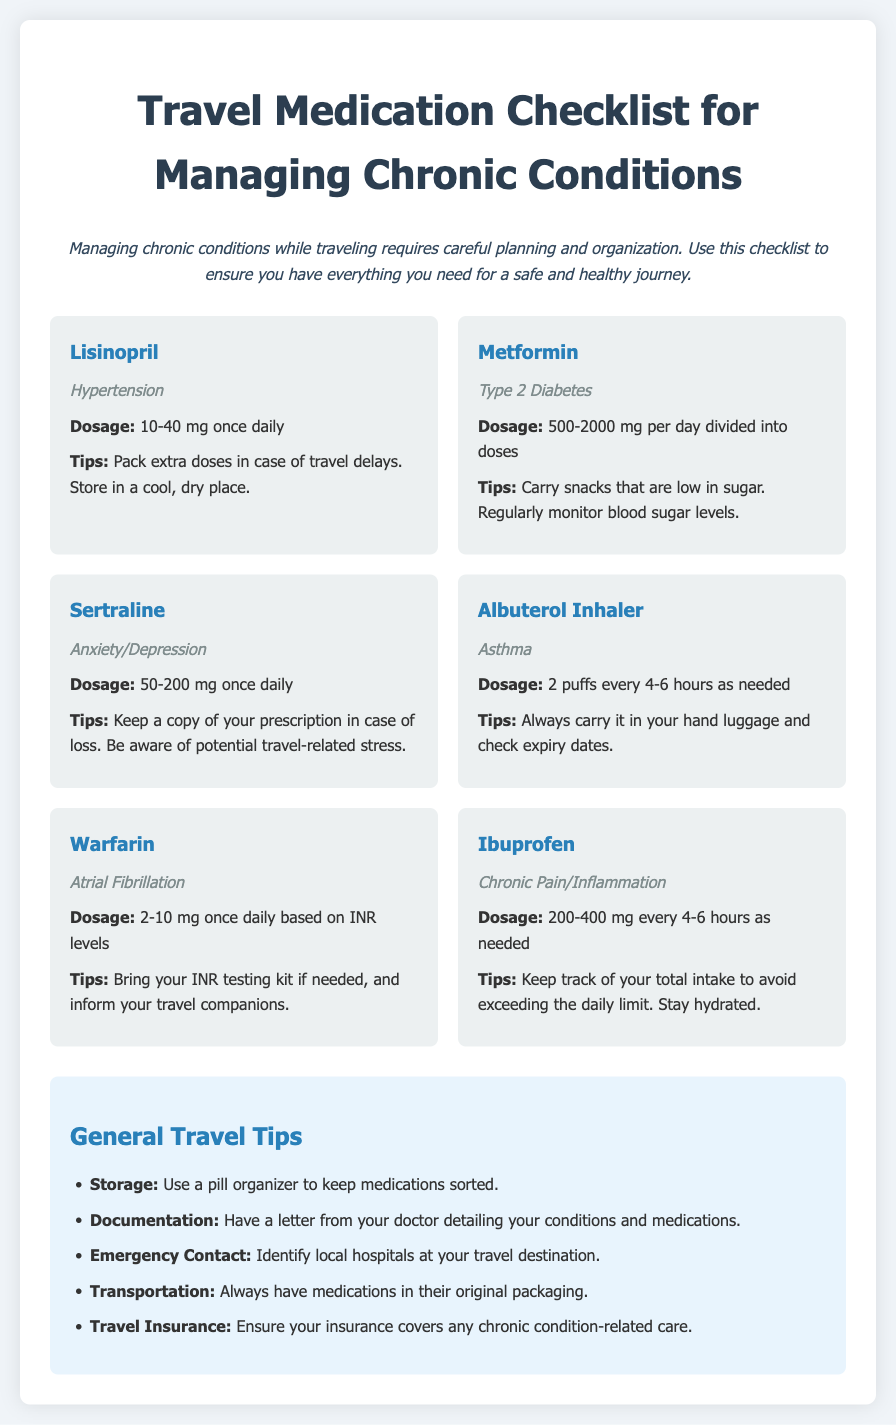What is the dosage for Lisinopril? The dosage for Lisinopril is specified as 10-40 mg once daily in the document.
Answer: 10-40 mg once daily How should Metformin be taken? The document states that Metformin should be taken as 500-2000 mg per day divided into doses.
Answer: 500-2000 mg per day divided into doses What condition is Sertraline prescribed for? The document indicates that Sertraline is prescribed for Anxiety/Depression.
Answer: Anxiety/Depression How many puffs of Albuterol Inhaler can be taken as needed? The document specifies that the dosage for Albuterol Inhaler is 2 puffs every 4-6 hours as needed.
Answer: 2 puffs every 4-6 hours What is a general travel tip regarding medication storage? The document suggests using a pill organizer to keep medications sorted.
Answer: Use a pill organizer What should you carry with you for emergency situations? According to the document, you should identify local hospitals at your travel destination.
Answer: Local hospitals What is the purpose of having a letter from your doctor? The document states that having a letter from your doctor is for detailing your conditions and medications.
Answer: Detailing conditions and medications What is the maximum dosage for Ibuprofen per intake? The document states Ibuprofen can be taken as 200-400 mg every 4-6 hours as needed.
Answer: 200-400 mg What should you do in case of losing your medication? The document suggests to keep a copy of your prescription in case of loss.
Answer: Keep a copy of your prescription 